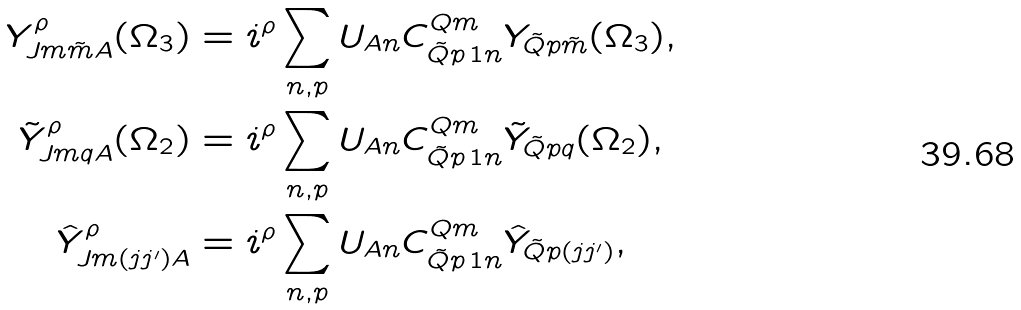Convert formula to latex. <formula><loc_0><loc_0><loc_500><loc_500>Y ^ { \rho } _ { J m \tilde { m } A } ( \Omega _ { 3 } ) & = i ^ { \rho } \sum _ { n , p } U _ { A n } C ^ { Q m } _ { \tilde { Q } p \, 1 n } Y _ { \tilde { Q } p \tilde { m } } ( \Omega _ { 3 } ) , \\ \tilde { Y } ^ { \rho } _ { J m q A } ( \Omega _ { 2 } ) & = i ^ { \rho } \sum _ { n , p } U _ { A n } C ^ { Q m } _ { \tilde { Q } p \, 1 n } \tilde { Y } _ { \tilde { Q } p q } ( \Omega _ { 2 } ) , \\ \hat { Y } ^ { \rho } _ { J m ( j j ^ { \prime } ) A } & = i ^ { \rho } \sum _ { n , p } U _ { A n } C ^ { Q m } _ { \tilde { Q } p \, 1 n } \hat { Y } _ { \tilde { Q } p ( j j ^ { \prime } ) } ,</formula> 